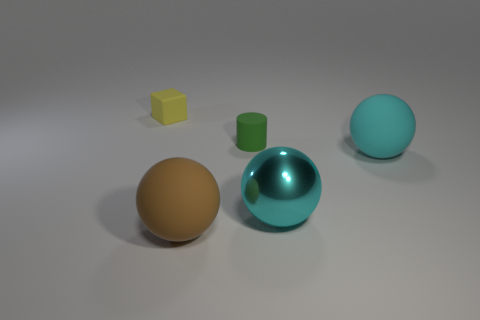Is the number of objects that are on the right side of the small matte block less than the number of cyan matte things?
Keep it short and to the point. No. How many big rubber objects are the same color as the metal sphere?
Provide a short and direct response. 1. What is the material of the thing that is on the left side of the small matte cylinder and right of the small yellow thing?
Offer a terse response. Rubber. There is a big matte ball behind the cyan metallic thing; is it the same color as the tiny rubber object to the left of the big brown matte thing?
Keep it short and to the point. No. What number of cyan things are either large metallic balls or rubber balls?
Give a very brief answer. 2. Are there fewer spheres behind the large brown ball than large cyan rubber balls that are left of the matte cylinder?
Provide a succinct answer. No. Are there any brown cylinders of the same size as the green rubber cylinder?
Ensure brevity in your answer.  No. There is a matte sphere that is in front of the metallic sphere; does it have the same size as the cyan matte object?
Ensure brevity in your answer.  Yes. Are there more brown cubes than small yellow blocks?
Make the answer very short. No. Are there any other brown objects that have the same shape as the big shiny object?
Offer a very short reply. Yes. 